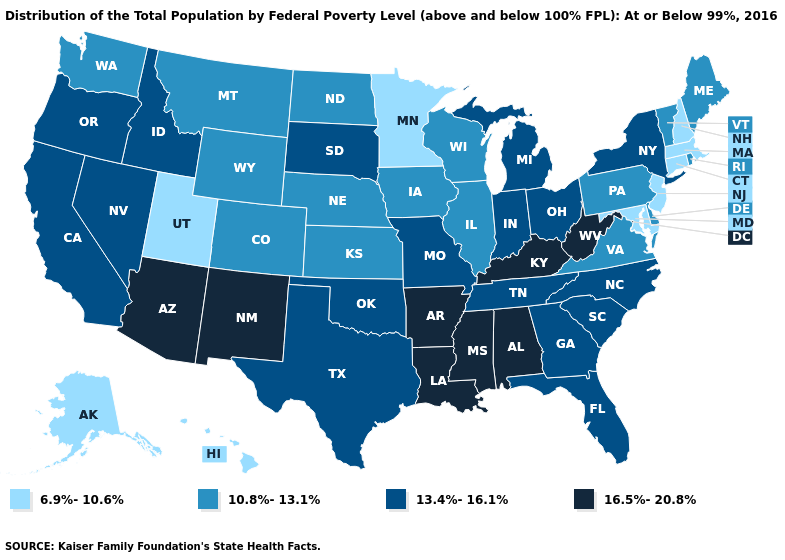Which states hav the highest value in the MidWest?
Write a very short answer. Indiana, Michigan, Missouri, Ohio, South Dakota. Name the states that have a value in the range 10.8%-13.1%?
Answer briefly. Colorado, Delaware, Illinois, Iowa, Kansas, Maine, Montana, Nebraska, North Dakota, Pennsylvania, Rhode Island, Vermont, Virginia, Washington, Wisconsin, Wyoming. Which states have the lowest value in the South?
Keep it brief. Maryland. Does the map have missing data?
Concise answer only. No. What is the lowest value in the Northeast?
Write a very short answer. 6.9%-10.6%. How many symbols are there in the legend?
Concise answer only. 4. What is the lowest value in states that border South Dakota?
Concise answer only. 6.9%-10.6%. What is the value of Pennsylvania?
Answer briefly. 10.8%-13.1%. How many symbols are there in the legend?
Concise answer only. 4. Among the states that border Wyoming , which have the lowest value?
Concise answer only. Utah. Name the states that have a value in the range 6.9%-10.6%?
Answer briefly. Alaska, Connecticut, Hawaii, Maryland, Massachusetts, Minnesota, New Hampshire, New Jersey, Utah. Among the states that border Michigan , which have the highest value?
Quick response, please. Indiana, Ohio. Name the states that have a value in the range 13.4%-16.1%?
Write a very short answer. California, Florida, Georgia, Idaho, Indiana, Michigan, Missouri, Nevada, New York, North Carolina, Ohio, Oklahoma, Oregon, South Carolina, South Dakota, Tennessee, Texas. Among the states that border North Carolina , does Virginia have the lowest value?
Short answer required. Yes. 